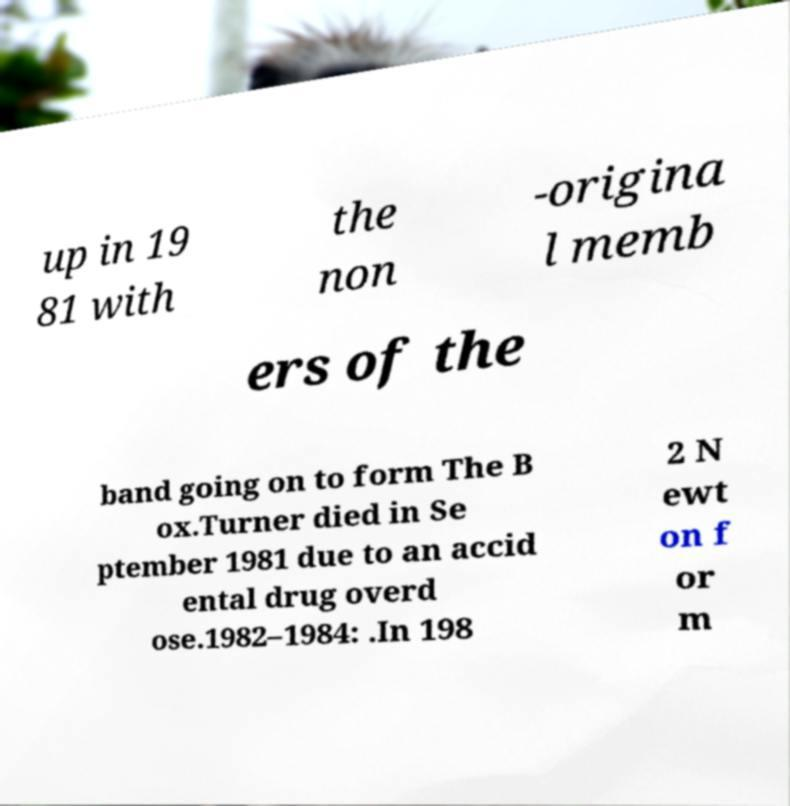I need the written content from this picture converted into text. Can you do that? up in 19 81 with the non -origina l memb ers of the band going on to form The B ox.Turner died in Se ptember 1981 due to an accid ental drug overd ose.1982–1984: .In 198 2 N ewt on f or m 